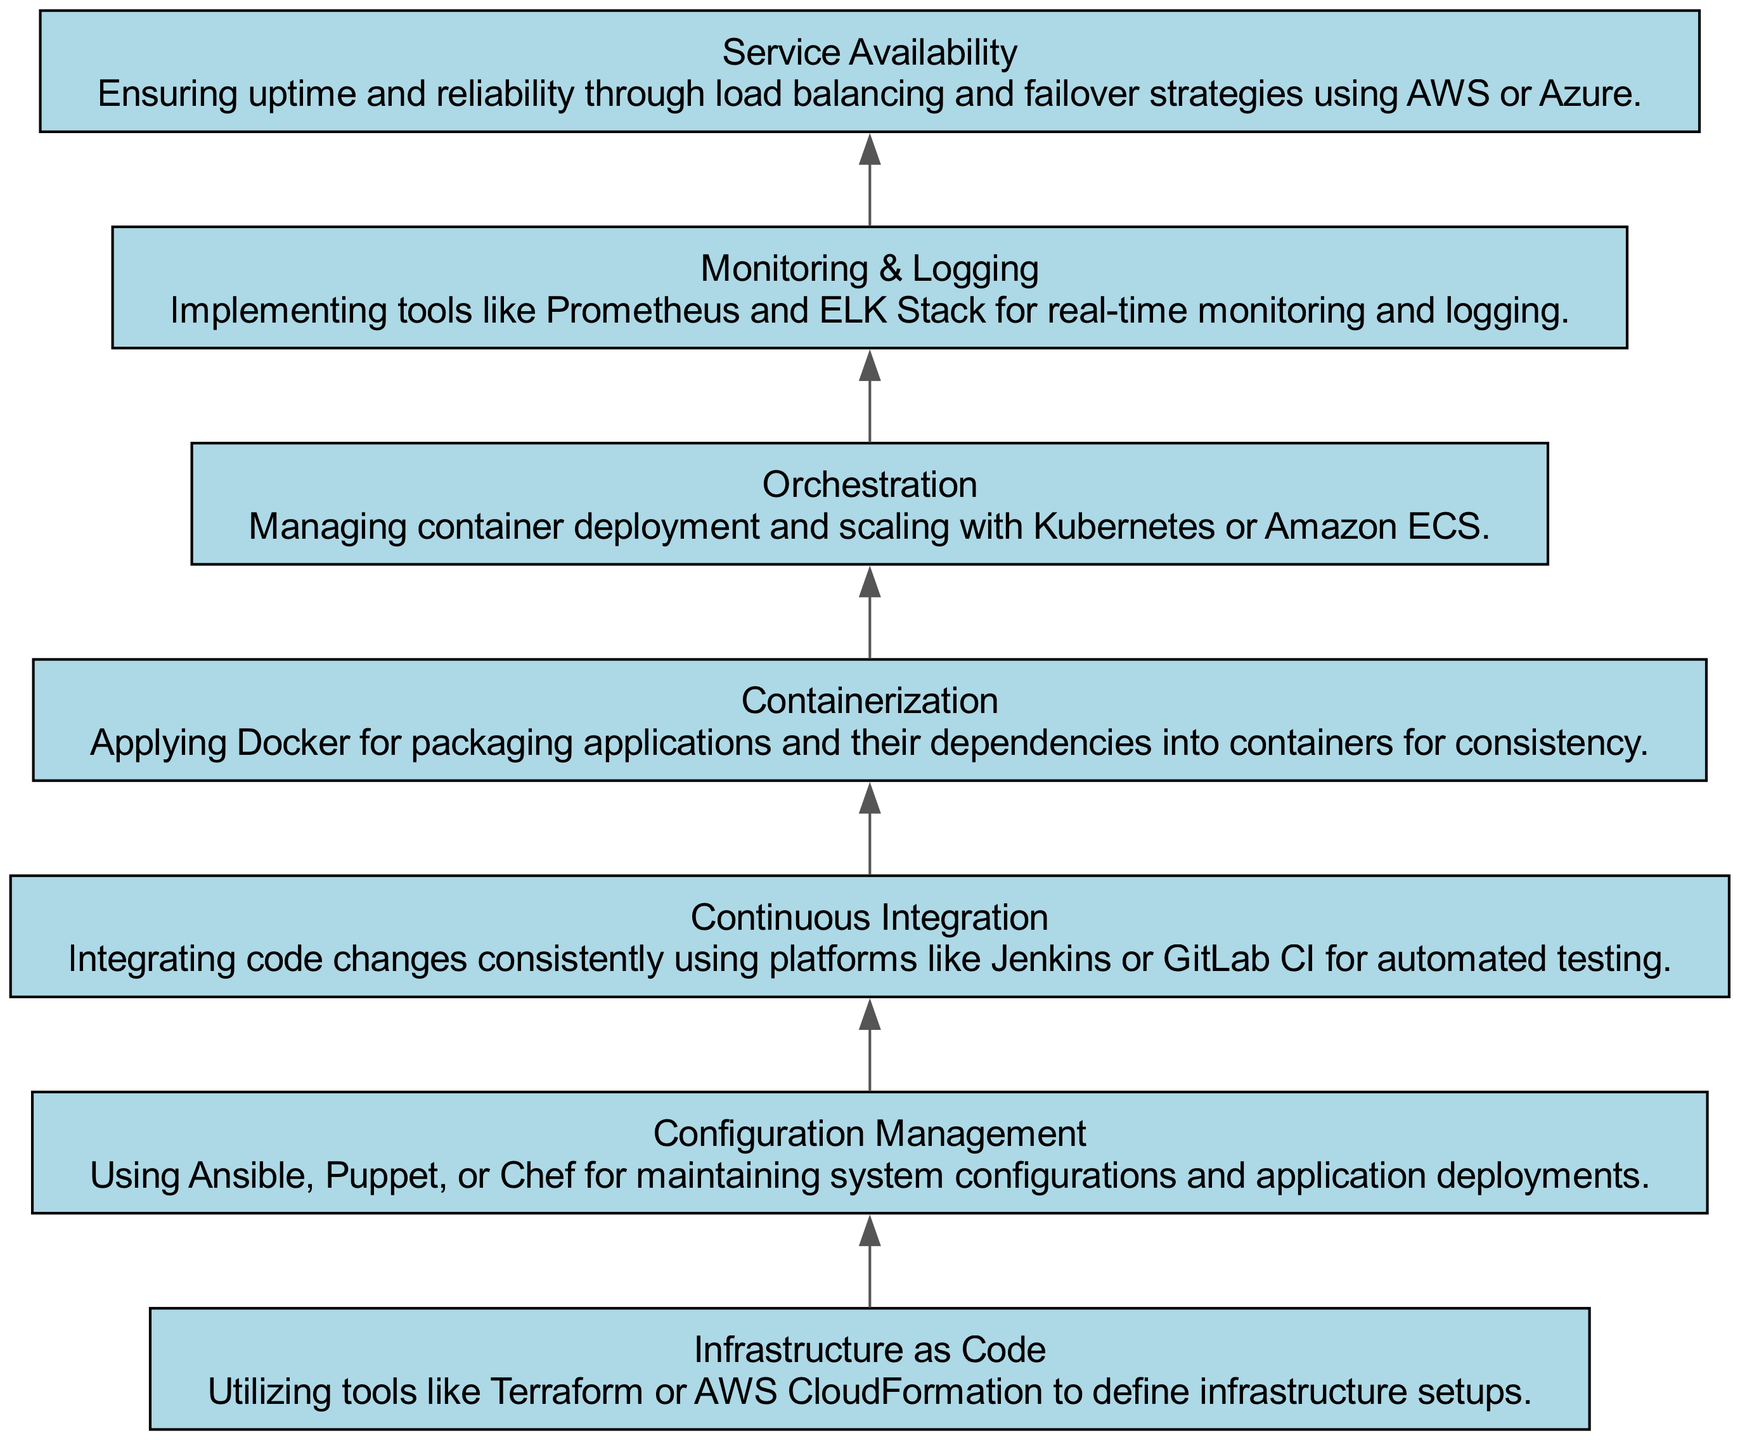What is the first step in the infrastructure deployment process? The diagram starts with "Infrastructure as Code," indicating it as the initial step in the process.
Answer: Infrastructure as Code How many nodes are depicted in the diagram? The diagram lists seven distinct elements, which are visually represented as nodes.
Answer: Seven Which node comes immediately after "Continuous Integration"? Following "Continuous Integration," the next node in the sequence is "Containerization," showing the progression from integrating code changes to packaging applications.
Answer: Containerization What is the last step in the infrastructure deployment process? The final node in the flowchart is "Service Availability," indicating it is the ultimate step to ensure the services are reachable and reliable.
Answer: Service Availability What two nodes are directly connected to "Monitoring & Logging"? From the diagram, "Monitoring & Logging" directly connects to "Service Availability" and "Orchestration," indicating its role in the broader deployment process.
Answer: Service Availability and Orchestration Which nodal step integrates code changes for testing? The "Continuous Integration" node is where code changes are integrated on a consistent basis, highlighting its significance in the testing phase of the deployment process.
Answer: Continuous Integration In which node do you define infrastructure setups? The "Infrastructure as Code" node is dedicated to defining infrastructure setups using various tools, showcasing its foundational role in deployments.
Answer: Infrastructure as Code What is the relationship between "Containerization" and "Orchestration"? "Containerization" leads to "Orchestration," indicating that once applications are packaged into containers, they require orchestration for deployment management.
Answer: Leads to How many connections are made from "Configuration Management"? "Configuration Management" connects to "Continuous Integration," making a single direct connection, illustrating its sequential involvement in the deployment steps.
Answer: One 